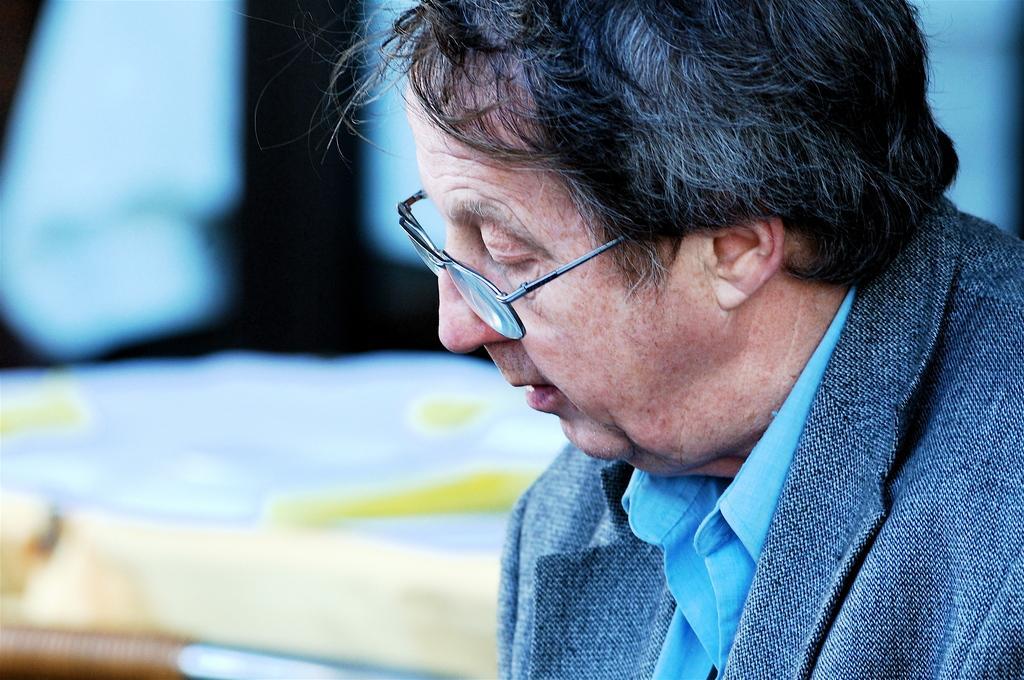Please provide a concise description of this image. On the right side of the image we can see a person and the person wore spectacles, also we can see blurry background. 